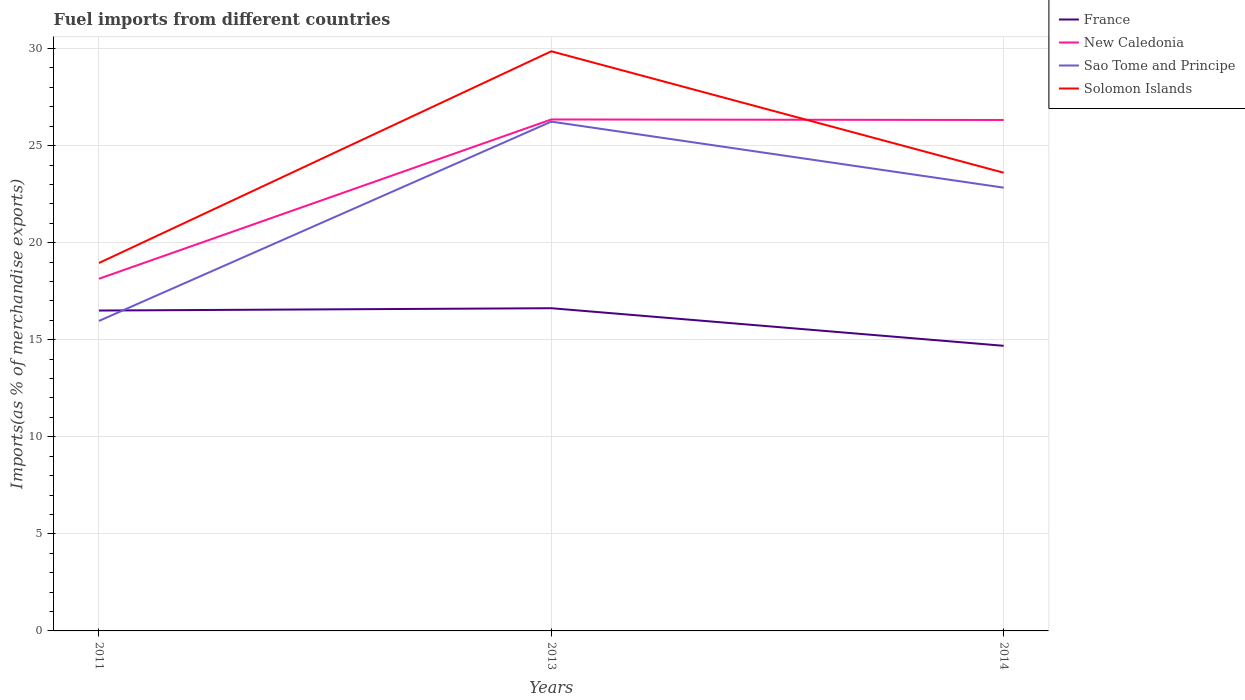How many different coloured lines are there?
Provide a short and direct response. 4. Does the line corresponding to Sao Tome and Principe intersect with the line corresponding to France?
Offer a terse response. Yes. Is the number of lines equal to the number of legend labels?
Keep it short and to the point. Yes. Across all years, what is the maximum percentage of imports to different countries in New Caledonia?
Provide a succinct answer. 18.14. In which year was the percentage of imports to different countries in Solomon Islands maximum?
Make the answer very short. 2011. What is the total percentage of imports to different countries in Solomon Islands in the graph?
Make the answer very short. -10.91. What is the difference between the highest and the second highest percentage of imports to different countries in New Caledonia?
Offer a very short reply. 8.21. How many lines are there?
Ensure brevity in your answer.  4. How many years are there in the graph?
Your response must be concise. 3. Are the values on the major ticks of Y-axis written in scientific E-notation?
Offer a very short reply. No. Does the graph contain grids?
Make the answer very short. Yes. How many legend labels are there?
Provide a short and direct response. 4. What is the title of the graph?
Provide a short and direct response. Fuel imports from different countries. What is the label or title of the X-axis?
Your answer should be very brief. Years. What is the label or title of the Y-axis?
Provide a succinct answer. Imports(as % of merchandise exports). What is the Imports(as % of merchandise exports) of France in 2011?
Ensure brevity in your answer.  16.5. What is the Imports(as % of merchandise exports) in New Caledonia in 2011?
Offer a very short reply. 18.14. What is the Imports(as % of merchandise exports) in Sao Tome and Principe in 2011?
Ensure brevity in your answer.  15.97. What is the Imports(as % of merchandise exports) in Solomon Islands in 2011?
Offer a terse response. 18.95. What is the Imports(as % of merchandise exports) of France in 2013?
Keep it short and to the point. 16.62. What is the Imports(as % of merchandise exports) in New Caledonia in 2013?
Give a very brief answer. 26.35. What is the Imports(as % of merchandise exports) of Sao Tome and Principe in 2013?
Your response must be concise. 26.24. What is the Imports(as % of merchandise exports) in Solomon Islands in 2013?
Your answer should be very brief. 29.86. What is the Imports(as % of merchandise exports) in France in 2014?
Your response must be concise. 14.69. What is the Imports(as % of merchandise exports) in New Caledonia in 2014?
Provide a succinct answer. 26.32. What is the Imports(as % of merchandise exports) in Sao Tome and Principe in 2014?
Give a very brief answer. 22.83. What is the Imports(as % of merchandise exports) in Solomon Islands in 2014?
Provide a succinct answer. 23.6. Across all years, what is the maximum Imports(as % of merchandise exports) of France?
Your response must be concise. 16.62. Across all years, what is the maximum Imports(as % of merchandise exports) of New Caledonia?
Give a very brief answer. 26.35. Across all years, what is the maximum Imports(as % of merchandise exports) in Sao Tome and Principe?
Offer a very short reply. 26.24. Across all years, what is the maximum Imports(as % of merchandise exports) in Solomon Islands?
Give a very brief answer. 29.86. Across all years, what is the minimum Imports(as % of merchandise exports) in France?
Offer a very short reply. 14.69. Across all years, what is the minimum Imports(as % of merchandise exports) of New Caledonia?
Keep it short and to the point. 18.14. Across all years, what is the minimum Imports(as % of merchandise exports) in Sao Tome and Principe?
Offer a very short reply. 15.97. Across all years, what is the minimum Imports(as % of merchandise exports) in Solomon Islands?
Your answer should be very brief. 18.95. What is the total Imports(as % of merchandise exports) in France in the graph?
Your answer should be compact. 47.81. What is the total Imports(as % of merchandise exports) in New Caledonia in the graph?
Give a very brief answer. 70.81. What is the total Imports(as % of merchandise exports) in Sao Tome and Principe in the graph?
Your response must be concise. 65.04. What is the total Imports(as % of merchandise exports) in Solomon Islands in the graph?
Ensure brevity in your answer.  72.41. What is the difference between the Imports(as % of merchandise exports) in France in 2011 and that in 2013?
Your response must be concise. -0.12. What is the difference between the Imports(as % of merchandise exports) of New Caledonia in 2011 and that in 2013?
Your answer should be very brief. -8.21. What is the difference between the Imports(as % of merchandise exports) in Sao Tome and Principe in 2011 and that in 2013?
Keep it short and to the point. -10.27. What is the difference between the Imports(as % of merchandise exports) in Solomon Islands in 2011 and that in 2013?
Your response must be concise. -10.9. What is the difference between the Imports(as % of merchandise exports) in France in 2011 and that in 2014?
Provide a short and direct response. 1.82. What is the difference between the Imports(as % of merchandise exports) of New Caledonia in 2011 and that in 2014?
Your answer should be very brief. -8.18. What is the difference between the Imports(as % of merchandise exports) in Sao Tome and Principe in 2011 and that in 2014?
Your response must be concise. -6.87. What is the difference between the Imports(as % of merchandise exports) in Solomon Islands in 2011 and that in 2014?
Offer a very short reply. -4.65. What is the difference between the Imports(as % of merchandise exports) in France in 2013 and that in 2014?
Offer a very short reply. 1.94. What is the difference between the Imports(as % of merchandise exports) in New Caledonia in 2013 and that in 2014?
Make the answer very short. 0.03. What is the difference between the Imports(as % of merchandise exports) of Sao Tome and Principe in 2013 and that in 2014?
Your response must be concise. 3.4. What is the difference between the Imports(as % of merchandise exports) in Solomon Islands in 2013 and that in 2014?
Offer a terse response. 6.25. What is the difference between the Imports(as % of merchandise exports) in France in 2011 and the Imports(as % of merchandise exports) in New Caledonia in 2013?
Give a very brief answer. -9.84. What is the difference between the Imports(as % of merchandise exports) in France in 2011 and the Imports(as % of merchandise exports) in Sao Tome and Principe in 2013?
Your answer should be compact. -9.73. What is the difference between the Imports(as % of merchandise exports) of France in 2011 and the Imports(as % of merchandise exports) of Solomon Islands in 2013?
Ensure brevity in your answer.  -13.35. What is the difference between the Imports(as % of merchandise exports) of New Caledonia in 2011 and the Imports(as % of merchandise exports) of Sao Tome and Principe in 2013?
Your answer should be very brief. -8.09. What is the difference between the Imports(as % of merchandise exports) of New Caledonia in 2011 and the Imports(as % of merchandise exports) of Solomon Islands in 2013?
Offer a terse response. -11.72. What is the difference between the Imports(as % of merchandise exports) of Sao Tome and Principe in 2011 and the Imports(as % of merchandise exports) of Solomon Islands in 2013?
Offer a very short reply. -13.89. What is the difference between the Imports(as % of merchandise exports) of France in 2011 and the Imports(as % of merchandise exports) of New Caledonia in 2014?
Give a very brief answer. -9.82. What is the difference between the Imports(as % of merchandise exports) of France in 2011 and the Imports(as % of merchandise exports) of Sao Tome and Principe in 2014?
Your response must be concise. -6.33. What is the difference between the Imports(as % of merchandise exports) in France in 2011 and the Imports(as % of merchandise exports) in Solomon Islands in 2014?
Provide a succinct answer. -7.1. What is the difference between the Imports(as % of merchandise exports) of New Caledonia in 2011 and the Imports(as % of merchandise exports) of Sao Tome and Principe in 2014?
Make the answer very short. -4.69. What is the difference between the Imports(as % of merchandise exports) in New Caledonia in 2011 and the Imports(as % of merchandise exports) in Solomon Islands in 2014?
Make the answer very short. -5.46. What is the difference between the Imports(as % of merchandise exports) of Sao Tome and Principe in 2011 and the Imports(as % of merchandise exports) of Solomon Islands in 2014?
Your answer should be compact. -7.63. What is the difference between the Imports(as % of merchandise exports) of France in 2013 and the Imports(as % of merchandise exports) of New Caledonia in 2014?
Give a very brief answer. -9.7. What is the difference between the Imports(as % of merchandise exports) of France in 2013 and the Imports(as % of merchandise exports) of Sao Tome and Principe in 2014?
Offer a terse response. -6.21. What is the difference between the Imports(as % of merchandise exports) of France in 2013 and the Imports(as % of merchandise exports) of Solomon Islands in 2014?
Provide a succinct answer. -6.98. What is the difference between the Imports(as % of merchandise exports) of New Caledonia in 2013 and the Imports(as % of merchandise exports) of Sao Tome and Principe in 2014?
Provide a short and direct response. 3.51. What is the difference between the Imports(as % of merchandise exports) in New Caledonia in 2013 and the Imports(as % of merchandise exports) in Solomon Islands in 2014?
Your answer should be very brief. 2.74. What is the difference between the Imports(as % of merchandise exports) in Sao Tome and Principe in 2013 and the Imports(as % of merchandise exports) in Solomon Islands in 2014?
Your answer should be compact. 2.63. What is the average Imports(as % of merchandise exports) in France per year?
Give a very brief answer. 15.94. What is the average Imports(as % of merchandise exports) in New Caledonia per year?
Give a very brief answer. 23.6. What is the average Imports(as % of merchandise exports) of Sao Tome and Principe per year?
Offer a very short reply. 21.68. What is the average Imports(as % of merchandise exports) of Solomon Islands per year?
Your response must be concise. 24.14. In the year 2011, what is the difference between the Imports(as % of merchandise exports) of France and Imports(as % of merchandise exports) of New Caledonia?
Provide a succinct answer. -1.64. In the year 2011, what is the difference between the Imports(as % of merchandise exports) in France and Imports(as % of merchandise exports) in Sao Tome and Principe?
Provide a short and direct response. 0.54. In the year 2011, what is the difference between the Imports(as % of merchandise exports) in France and Imports(as % of merchandise exports) in Solomon Islands?
Your response must be concise. -2.45. In the year 2011, what is the difference between the Imports(as % of merchandise exports) in New Caledonia and Imports(as % of merchandise exports) in Sao Tome and Principe?
Give a very brief answer. 2.17. In the year 2011, what is the difference between the Imports(as % of merchandise exports) of New Caledonia and Imports(as % of merchandise exports) of Solomon Islands?
Give a very brief answer. -0.81. In the year 2011, what is the difference between the Imports(as % of merchandise exports) of Sao Tome and Principe and Imports(as % of merchandise exports) of Solomon Islands?
Your answer should be very brief. -2.98. In the year 2013, what is the difference between the Imports(as % of merchandise exports) of France and Imports(as % of merchandise exports) of New Caledonia?
Your answer should be very brief. -9.72. In the year 2013, what is the difference between the Imports(as % of merchandise exports) in France and Imports(as % of merchandise exports) in Sao Tome and Principe?
Provide a short and direct response. -9.61. In the year 2013, what is the difference between the Imports(as % of merchandise exports) of France and Imports(as % of merchandise exports) of Solomon Islands?
Provide a succinct answer. -13.23. In the year 2013, what is the difference between the Imports(as % of merchandise exports) of New Caledonia and Imports(as % of merchandise exports) of Sao Tome and Principe?
Give a very brief answer. 0.11. In the year 2013, what is the difference between the Imports(as % of merchandise exports) of New Caledonia and Imports(as % of merchandise exports) of Solomon Islands?
Make the answer very short. -3.51. In the year 2013, what is the difference between the Imports(as % of merchandise exports) in Sao Tome and Principe and Imports(as % of merchandise exports) in Solomon Islands?
Provide a succinct answer. -3.62. In the year 2014, what is the difference between the Imports(as % of merchandise exports) of France and Imports(as % of merchandise exports) of New Caledonia?
Provide a succinct answer. -11.63. In the year 2014, what is the difference between the Imports(as % of merchandise exports) of France and Imports(as % of merchandise exports) of Sao Tome and Principe?
Provide a succinct answer. -8.15. In the year 2014, what is the difference between the Imports(as % of merchandise exports) of France and Imports(as % of merchandise exports) of Solomon Islands?
Your answer should be very brief. -8.92. In the year 2014, what is the difference between the Imports(as % of merchandise exports) of New Caledonia and Imports(as % of merchandise exports) of Sao Tome and Principe?
Your answer should be very brief. 3.49. In the year 2014, what is the difference between the Imports(as % of merchandise exports) of New Caledonia and Imports(as % of merchandise exports) of Solomon Islands?
Ensure brevity in your answer.  2.72. In the year 2014, what is the difference between the Imports(as % of merchandise exports) of Sao Tome and Principe and Imports(as % of merchandise exports) of Solomon Islands?
Offer a terse response. -0.77. What is the ratio of the Imports(as % of merchandise exports) of France in 2011 to that in 2013?
Make the answer very short. 0.99. What is the ratio of the Imports(as % of merchandise exports) of New Caledonia in 2011 to that in 2013?
Provide a short and direct response. 0.69. What is the ratio of the Imports(as % of merchandise exports) in Sao Tome and Principe in 2011 to that in 2013?
Give a very brief answer. 0.61. What is the ratio of the Imports(as % of merchandise exports) in Solomon Islands in 2011 to that in 2013?
Make the answer very short. 0.63. What is the ratio of the Imports(as % of merchandise exports) in France in 2011 to that in 2014?
Your response must be concise. 1.12. What is the ratio of the Imports(as % of merchandise exports) of New Caledonia in 2011 to that in 2014?
Provide a short and direct response. 0.69. What is the ratio of the Imports(as % of merchandise exports) in Sao Tome and Principe in 2011 to that in 2014?
Give a very brief answer. 0.7. What is the ratio of the Imports(as % of merchandise exports) in Solomon Islands in 2011 to that in 2014?
Your answer should be very brief. 0.8. What is the ratio of the Imports(as % of merchandise exports) of France in 2013 to that in 2014?
Provide a short and direct response. 1.13. What is the ratio of the Imports(as % of merchandise exports) in Sao Tome and Principe in 2013 to that in 2014?
Provide a short and direct response. 1.15. What is the ratio of the Imports(as % of merchandise exports) of Solomon Islands in 2013 to that in 2014?
Your answer should be compact. 1.26. What is the difference between the highest and the second highest Imports(as % of merchandise exports) in France?
Keep it short and to the point. 0.12. What is the difference between the highest and the second highest Imports(as % of merchandise exports) of New Caledonia?
Your answer should be very brief. 0.03. What is the difference between the highest and the second highest Imports(as % of merchandise exports) in Sao Tome and Principe?
Your response must be concise. 3.4. What is the difference between the highest and the second highest Imports(as % of merchandise exports) in Solomon Islands?
Ensure brevity in your answer.  6.25. What is the difference between the highest and the lowest Imports(as % of merchandise exports) of France?
Give a very brief answer. 1.94. What is the difference between the highest and the lowest Imports(as % of merchandise exports) of New Caledonia?
Your answer should be very brief. 8.21. What is the difference between the highest and the lowest Imports(as % of merchandise exports) of Sao Tome and Principe?
Provide a short and direct response. 10.27. What is the difference between the highest and the lowest Imports(as % of merchandise exports) in Solomon Islands?
Offer a very short reply. 10.9. 